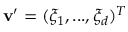Convert formula to latex. <formula><loc_0><loc_0><loc_500><loc_500>\mathbf v ^ { \prime } = ( \xi _ { 1 } , \dots , \xi _ { d } ) ^ { T }</formula> 